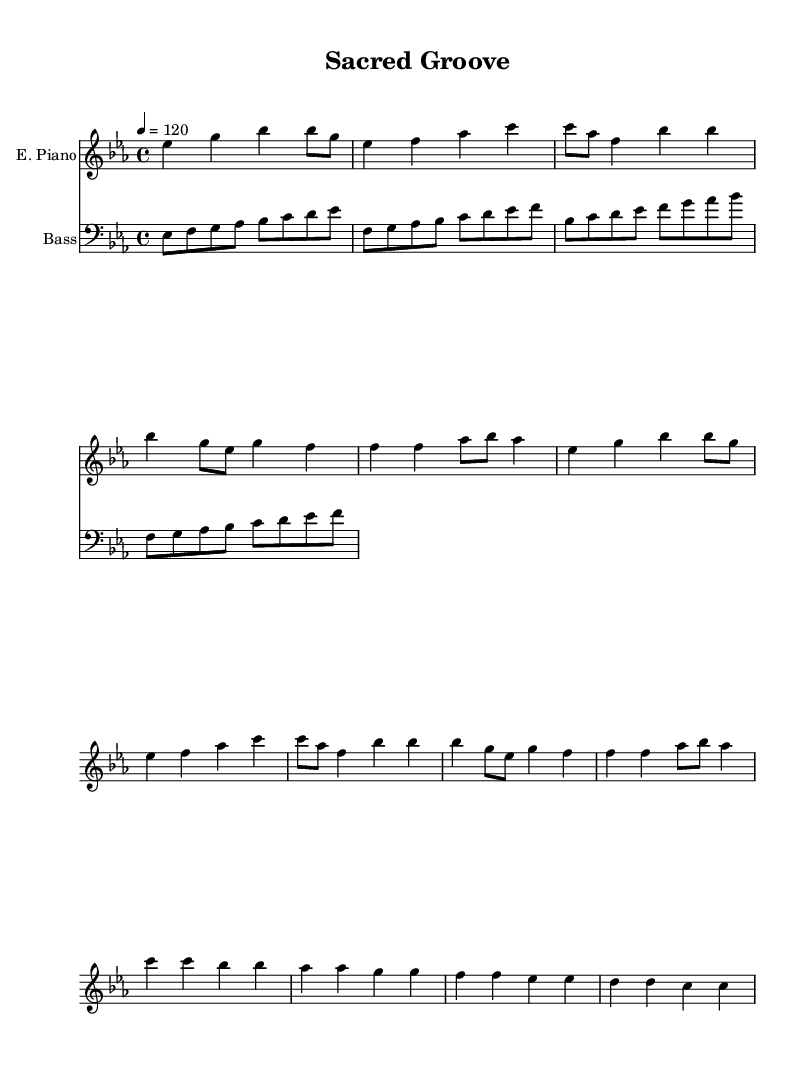What is the key signature of this music? The key signature is Es major, which has three flats (Bb, Eb, Ab). This can be identified by looking at the key signature notation located at the beginning of the staff lines.
Answer: Es major What is the time signature of the music? The time signature is 4/4, which can be determined by the fraction appearing at the beginning of the sheet music. This indicates that there are four beats per measure.
Answer: 4/4 What is the tempo marking for this piece? The tempo marking is 120, indicated in quarter notes. It is specified at the beginning of the score, meaning the music should be played at 120 beats per minute.
Answer: 120 What is the primary instrument for this piece? The primary instrument is the electric piano, which is noted at the start of the first staff. Instrument names are typically listed at the beginning of each staff.
Answer: E. Piano How many measures are there in the chorus section? There are 4 measures in the chorus section. By counting the measures from the start of the chorus phrase to its end, we confirm this total.
Answer: 4 What happens after the verse in terms of musical structure? After the verse, the music transitions to the chorus, enhancing the thematic expression of the piece. This is evident in the structure layout where the verse is followed directly by the chorus.
Answer: It transitions to the chorus What type of rhythm can you expect throughout this piece? This piece maintains a consistent dance rhythm, characterized by a driving four-beat pattern typical of funk and disco music. This is observed by analyzing the rhythmic patterns across the measures.
Answer: Dance rhythm 